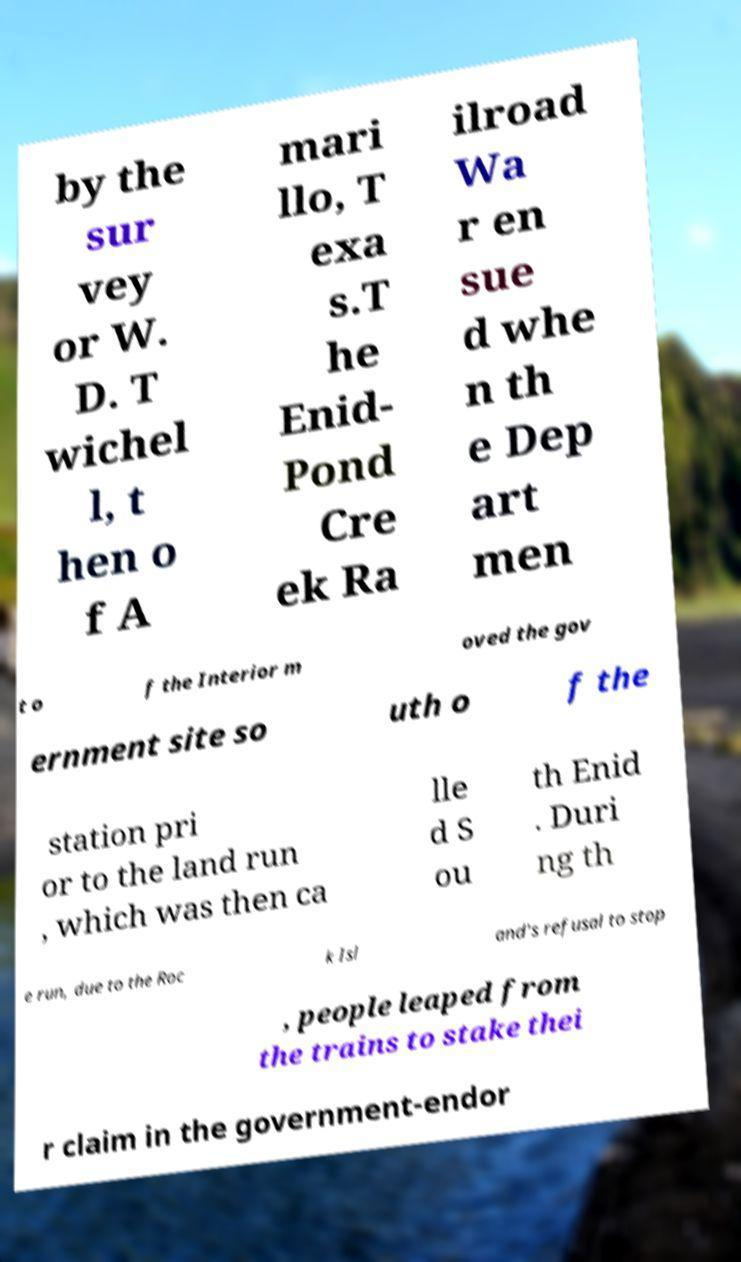I need the written content from this picture converted into text. Can you do that? by the sur vey or W. D. T wichel l, t hen o f A mari llo, T exa s.T he Enid- Pond Cre ek Ra ilroad Wa r en sue d whe n th e Dep art men t o f the Interior m oved the gov ernment site so uth o f the station pri or to the land run , which was then ca lle d S ou th Enid . Duri ng th e run, due to the Roc k Isl and's refusal to stop , people leaped from the trains to stake thei r claim in the government-endor 